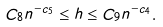<formula> <loc_0><loc_0><loc_500><loc_500>C _ { 8 } n ^ { - c _ { 5 } } \leq h \leq C _ { 9 } n ^ { - c _ { 4 } } .</formula> 